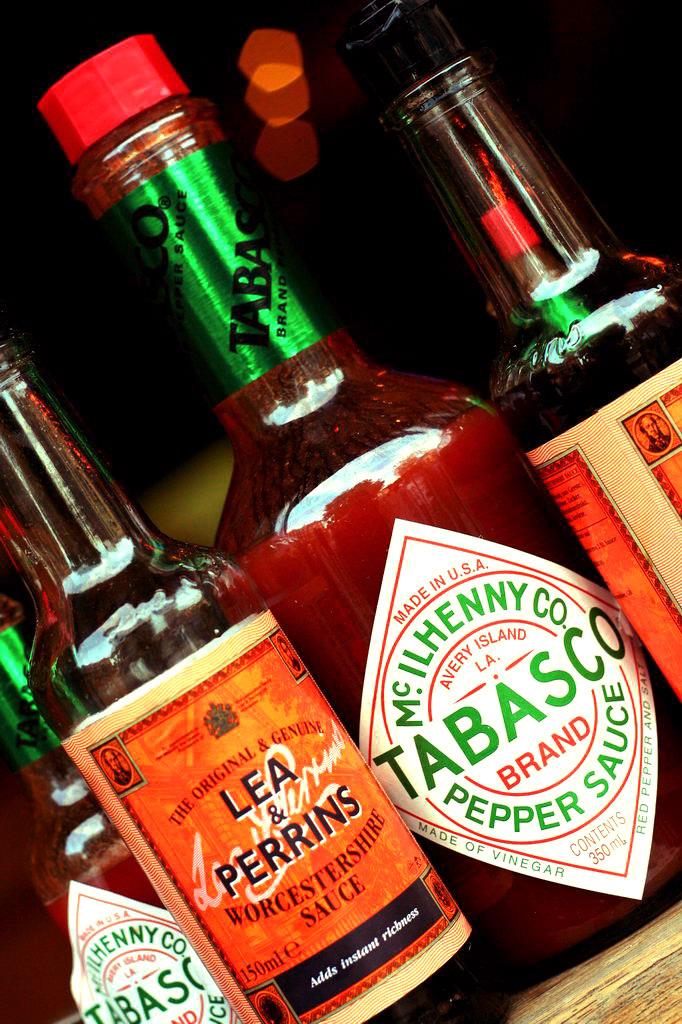What type of sauce is tabasco?
Your response must be concise. Pepper sauce. What type of sauce is in the near bottle with the orange label?
Keep it short and to the point. Tabasco. 